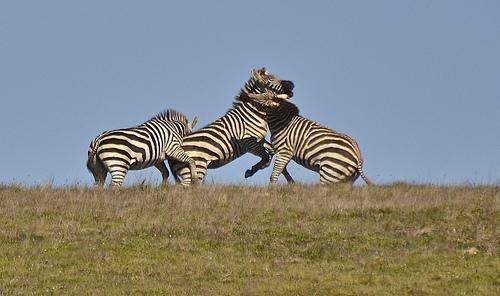How many zebras are in the picture?
Give a very brief answer. 3. How many clouds are in the picture?
Give a very brief answer. 0. 